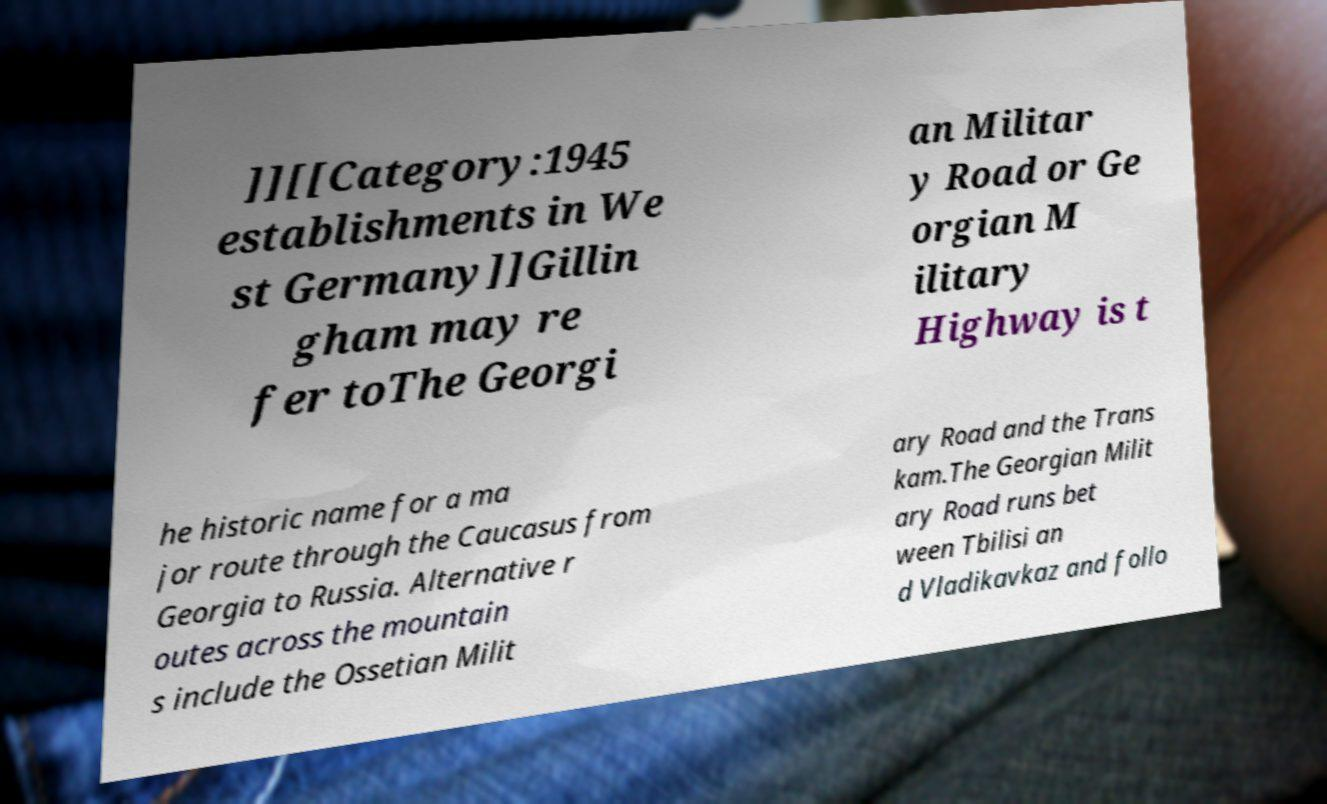Could you assist in decoding the text presented in this image and type it out clearly? ]][[Category:1945 establishments in We st Germany]]Gillin gham may re fer toThe Georgi an Militar y Road or Ge orgian M ilitary Highway is t he historic name for a ma jor route through the Caucasus from Georgia to Russia. Alternative r outes across the mountain s include the Ossetian Milit ary Road and the Trans kam.The Georgian Milit ary Road runs bet ween Tbilisi an d Vladikavkaz and follo 